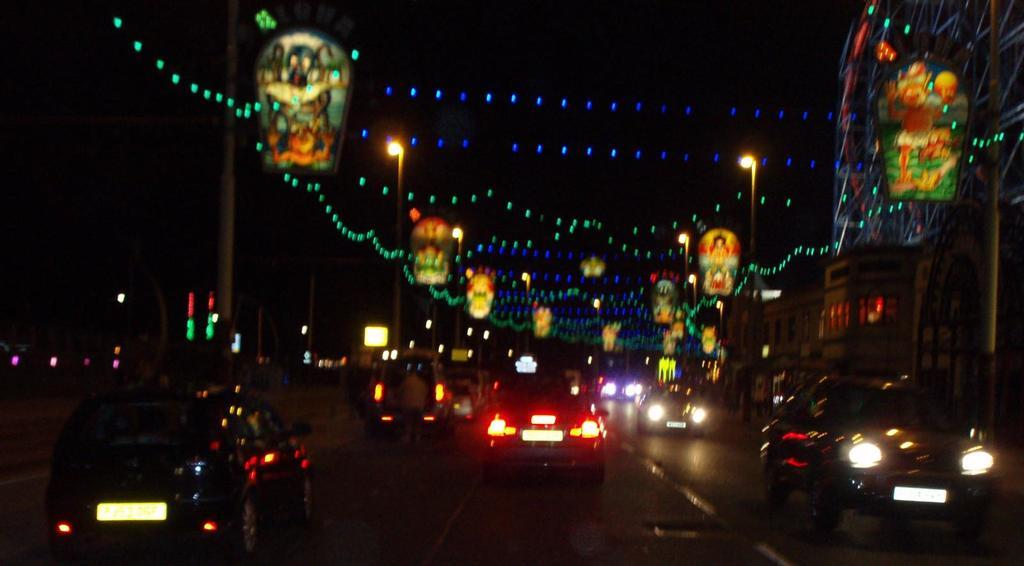What is the main feature of the image? There is a road in the image. What can be seen on the road? There are vehicles on the road. What else is visible in the image besides the road and vehicles? There are lights, buildings, street light poles, and boards visible in the image. How would you describe the sky in the background of the image? The sky is dark in the background of the image. Can you tell me the position of the berry on the road in the image? There is no berry present in the image, so its position cannot be determined. What type of exchange is happening between the vehicles in the image? The image does not show any exchange between the vehicles; it only depicts them on the road. 